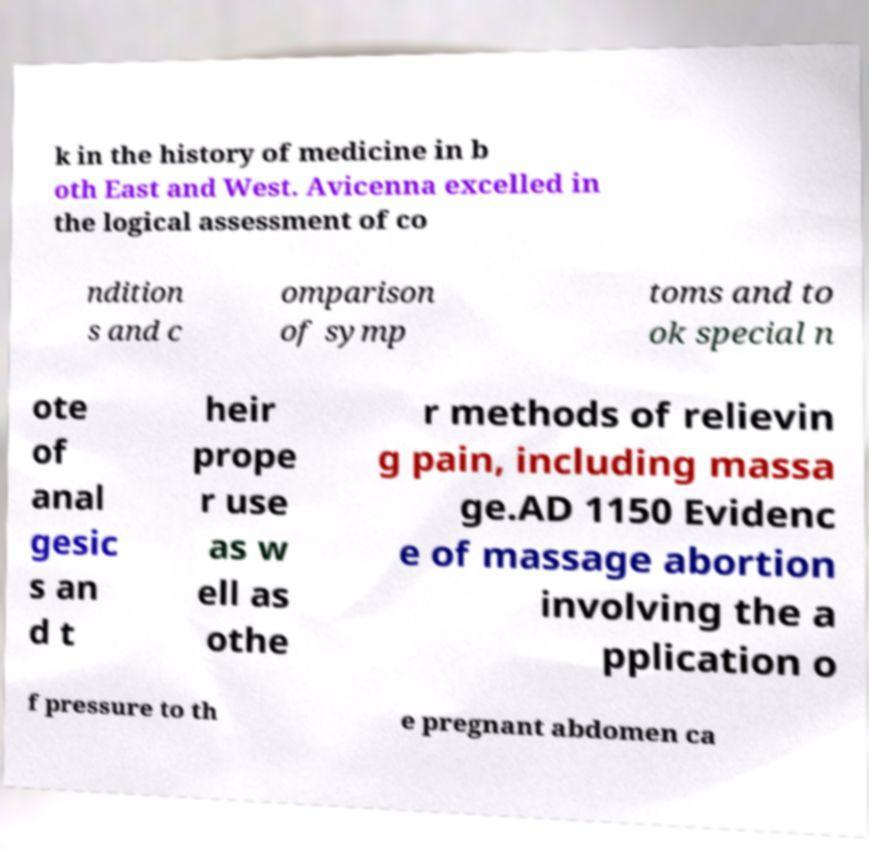Can you read and provide the text displayed in the image?This photo seems to have some interesting text. Can you extract and type it out for me? k in the history of medicine in b oth East and West. Avicenna excelled in the logical assessment of co ndition s and c omparison of symp toms and to ok special n ote of anal gesic s an d t heir prope r use as w ell as othe r methods of relievin g pain, including massa ge.AD 1150 Evidenc e of massage abortion involving the a pplication o f pressure to th e pregnant abdomen ca 